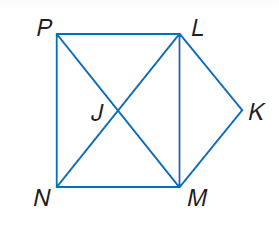Answer the mathemtical geometry problem and directly provide the correct option letter.
Question: Use rectangle L M N P, parallelogram L K M J to solve the problem. If M K = 6 x, K L = 3 x + 2 y, and J N = 14 - x, find y.
Choices: A: 2 B: 3 C: 6 D: 12 B 